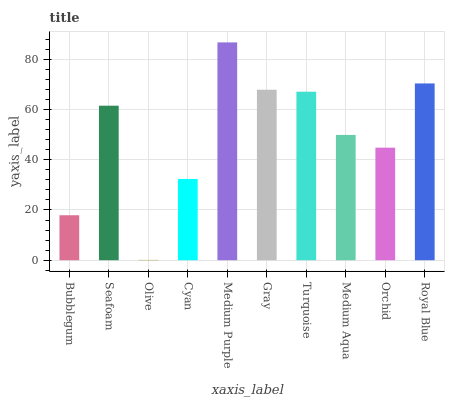Is Olive the minimum?
Answer yes or no. Yes. Is Medium Purple the maximum?
Answer yes or no. Yes. Is Seafoam the minimum?
Answer yes or no. No. Is Seafoam the maximum?
Answer yes or no. No. Is Seafoam greater than Bubblegum?
Answer yes or no. Yes. Is Bubblegum less than Seafoam?
Answer yes or no. Yes. Is Bubblegum greater than Seafoam?
Answer yes or no. No. Is Seafoam less than Bubblegum?
Answer yes or no. No. Is Seafoam the high median?
Answer yes or no. Yes. Is Medium Aqua the low median?
Answer yes or no. Yes. Is Orchid the high median?
Answer yes or no. No. Is Seafoam the low median?
Answer yes or no. No. 